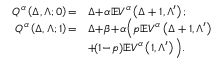Convert formula to latex. <formula><loc_0><loc_0><loc_500><loc_500>\begin{array} { r l } { Q ^ { \alpha } \left ( \Delta , \Lambda ; 0 \right ) \, = } & { \Delta \, + \, \alpha \mathbb { E } V ^ { \alpha } \left ( \Delta + 1 , \Lambda ^ { \prime } \right ) ; } \\ { Q ^ { \alpha } \left ( \Delta , \Lambda ; 1 \right ) \, = } & { \Delta \, + \, \beta \, + \, \alpha \left ( p \mathbb { E } V ^ { \alpha } \left ( \Delta + 1 , \Lambda ^ { \prime } \right ) } \\ & { + \, ( 1 \, - \, p ) \mathbb { E } V ^ { \alpha } \left ( 1 , \Lambda ^ { \prime } \right ) \right ) . } \end{array}</formula> 